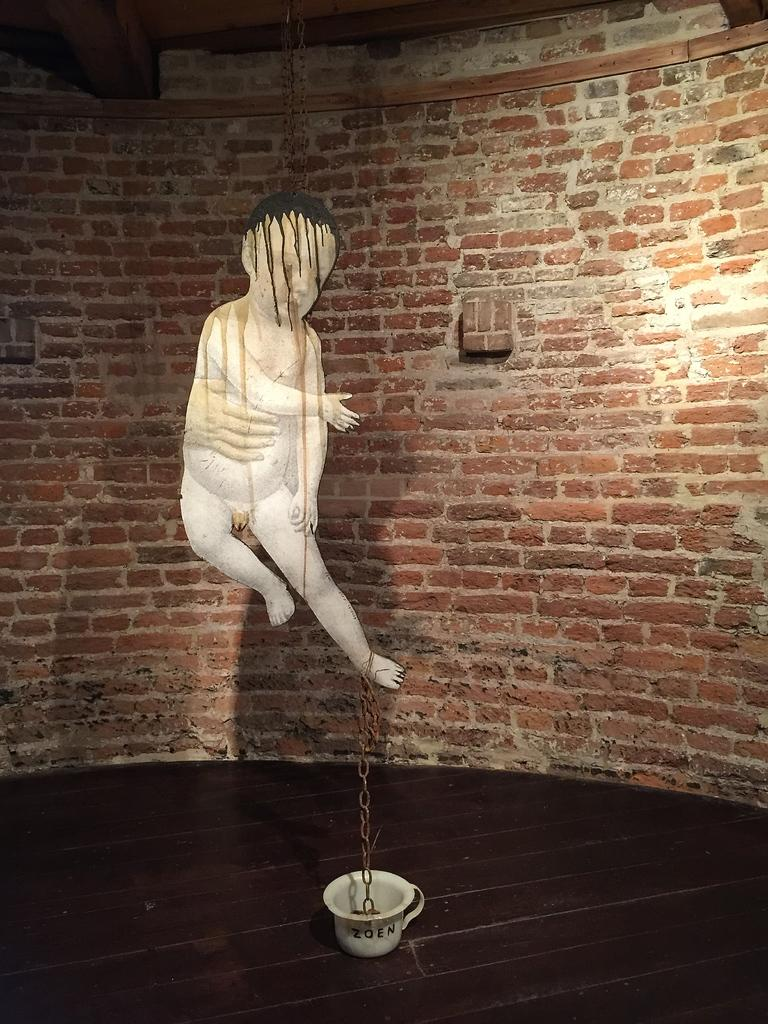What is the main subject of the image? There is a sculpture of a person in the image. What is the condition of the sculpture's leg? The sculpture's leg is tied with a chain. What object can be seen on the floor in the image? There is a white cup on the floor in the image. What type of structure is visible in the background of the image? There is a brick wall at the back of the image. What type of wool is being used to create the moon in the image? There is no moon or wool present in the image; it features a sculpture of a person with a chain-tied leg, a white cup on the floor, and a brick wall in the background. 